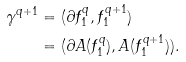Convert formula to latex. <formula><loc_0><loc_0><loc_500><loc_500>\gamma ^ { q + 1 } & = ( \partial f _ { 1 } ^ { q } , f _ { 1 } ^ { q + 1 } ) \\ & = ( \partial A ( f _ { 1 } ^ { q } ) , A ( f _ { 1 } ^ { q + 1 } ) ) .</formula> 